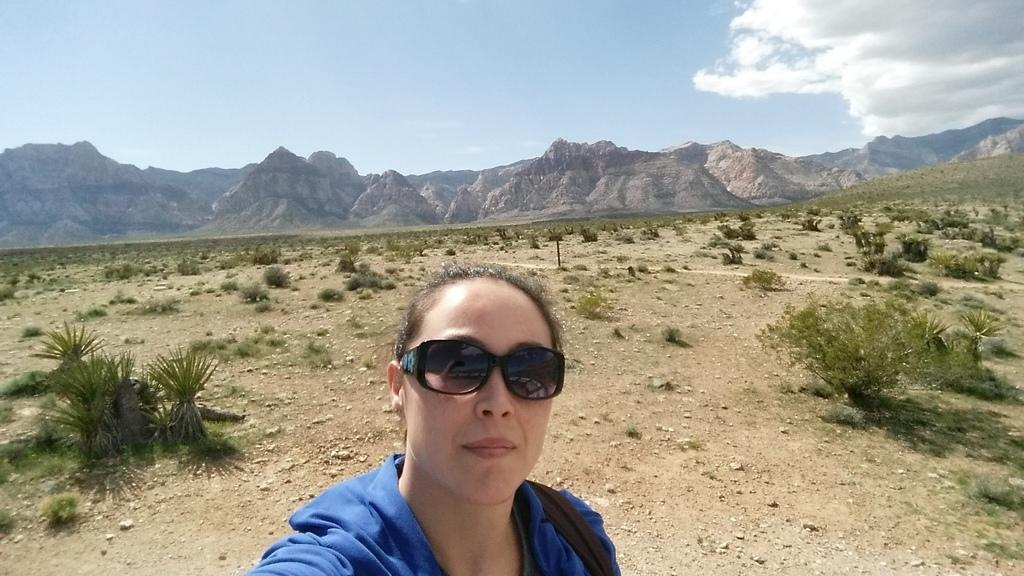Who is present in the image? There is a woman in the image. What is the woman wearing on her face? The woman is wearing goggles. What type of natural environment can be seen in the image? There are plants and mountains in the image. What is on the ground in the image? There are stones on the ground in the image. What is visible in the background of the image? The sky is visible in the background of the image, and clouds are present in the sky. Where is the tray located in the image? There is no tray present in the image. What type of bushes can be seen growing near the mountains in the image? There are no bushes mentioned in the image; only plants and mountains are described. 